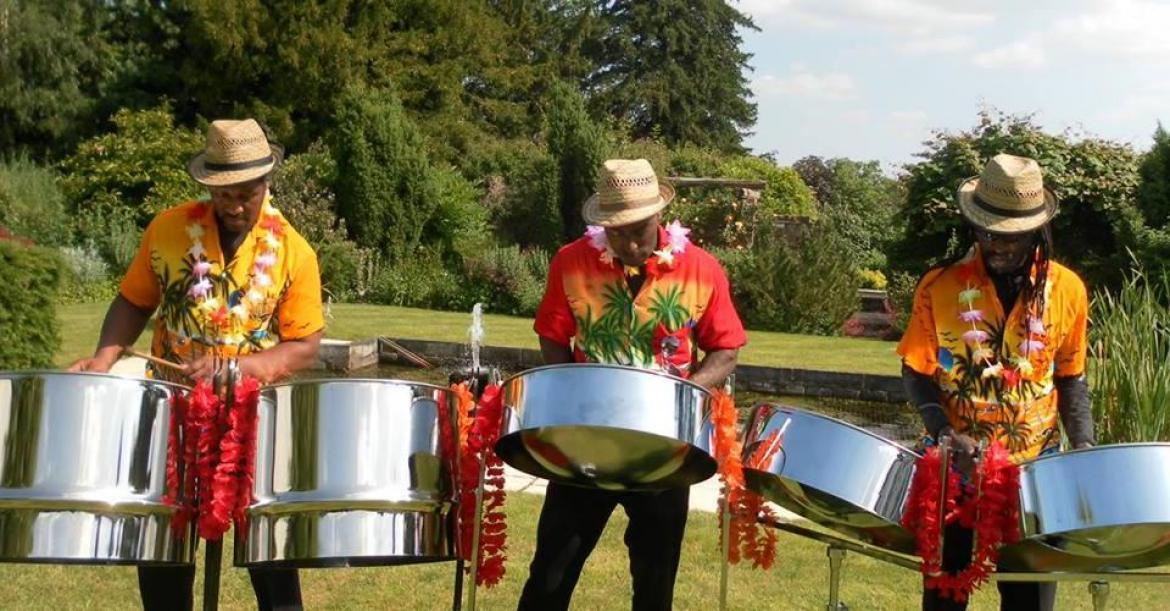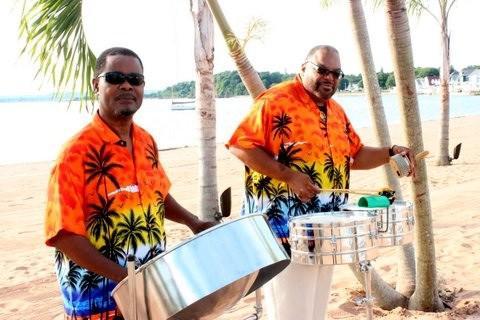The first image is the image on the left, the second image is the image on the right. Given the left and right images, does the statement "People are playing bongo drums." hold true? Answer yes or no. No. 